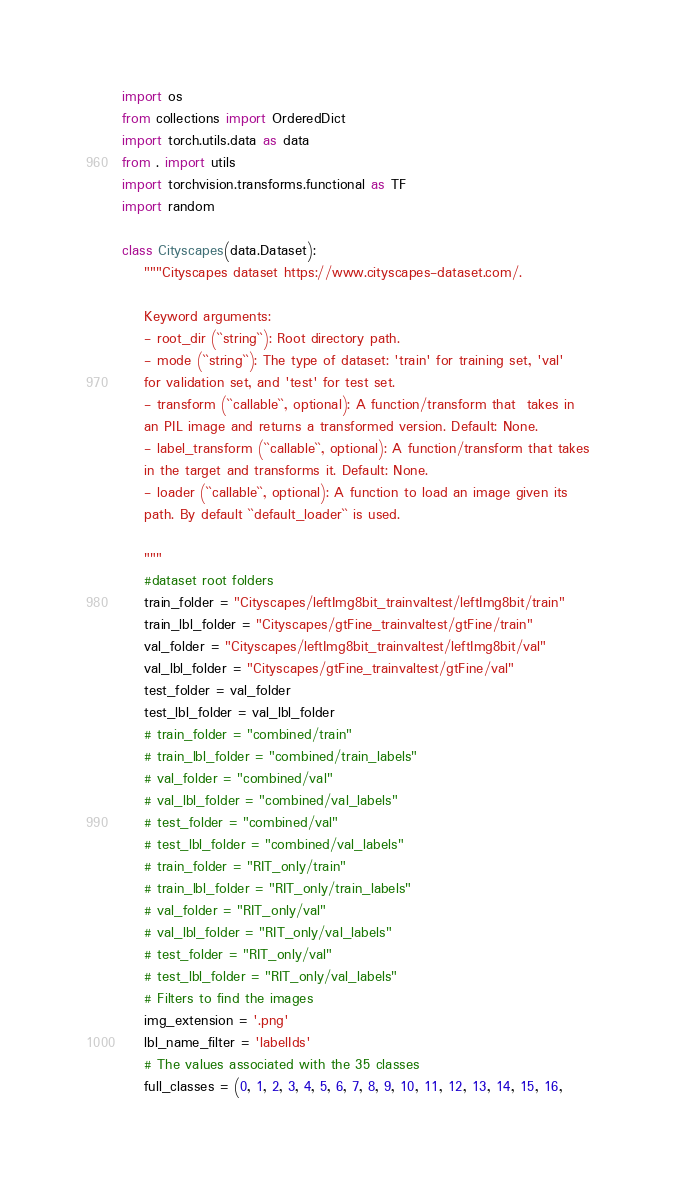Convert code to text. <code><loc_0><loc_0><loc_500><loc_500><_Python_>import os
from collections import OrderedDict
import torch.utils.data as data
from . import utils
import torchvision.transforms.functional as TF
import random

class Cityscapes(data.Dataset):
    """Cityscapes dataset https://www.cityscapes-dataset.com/.

    Keyword arguments:
    - root_dir (``string``): Root directory path.
    - mode (``string``): The type of dataset: 'train' for training set, 'val'
    for validation set, and 'test' for test set.
    - transform (``callable``, optional): A function/transform that  takes in
    an PIL image and returns a transformed version. Default: None.
    - label_transform (``callable``, optional): A function/transform that takes
    in the target and transforms it. Default: None.
    - loader (``callable``, optional): A function to load an image given its
    path. By default ``default_loader`` is used.

    """
    #dataset root folders
    train_folder = "Cityscapes/leftImg8bit_trainvaltest/leftImg8bit/train"
    train_lbl_folder = "Cityscapes/gtFine_trainvaltest/gtFine/train"
    val_folder = "Cityscapes/leftImg8bit_trainvaltest/leftImg8bit/val"
    val_lbl_folder = "Cityscapes/gtFine_trainvaltest/gtFine/val"
    test_folder = val_folder
    test_lbl_folder = val_lbl_folder
    # train_folder = "combined/train"
    # train_lbl_folder = "combined/train_labels"
    # val_folder = "combined/val"
    # val_lbl_folder = "combined/val_labels"
    # test_folder = "combined/val"
    # test_lbl_folder = "combined/val_labels"
    # train_folder = "RIT_only/train"
    # train_lbl_folder = "RIT_only/train_labels"
    # val_folder = "RIT_only/val"
    # val_lbl_folder = "RIT_only/val_labels"
    # test_folder = "RIT_only/val"
    # test_lbl_folder = "RIT_only/val_labels"
    # Filters to find the images
    img_extension = '.png'
    lbl_name_filter = 'labelIds'
    # The values associated with the 35 classes
    full_classes = (0, 1, 2, 3, 4, 5, 6, 7, 8, 9, 10, 11, 12, 13, 14, 15, 16,</code> 